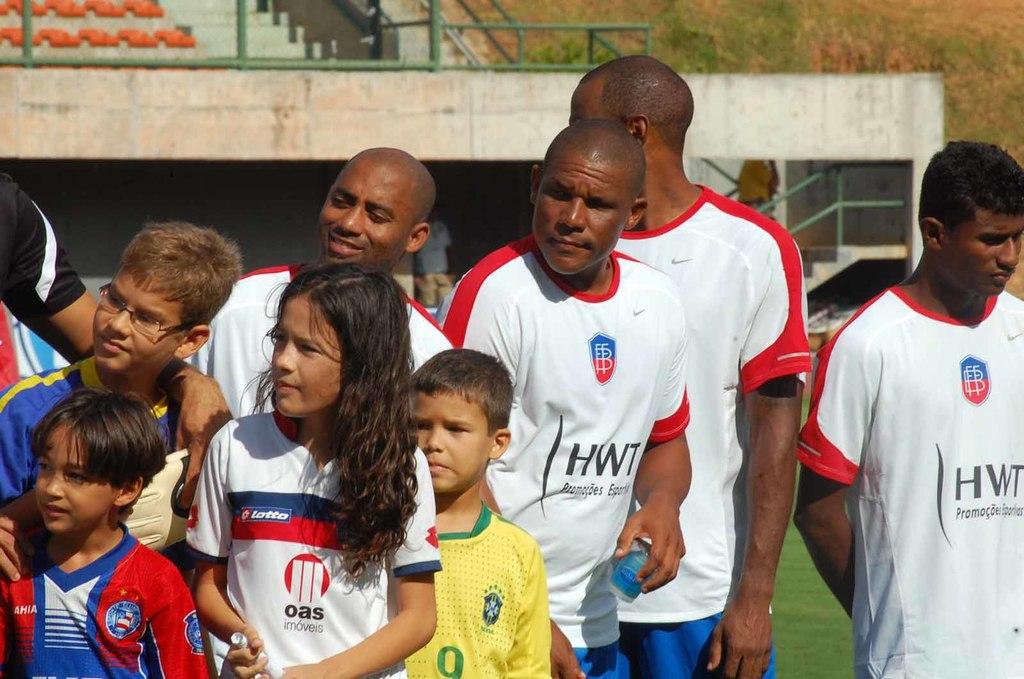What letters are on the adult jersey's?
Your answer should be very brief. Hwt. 